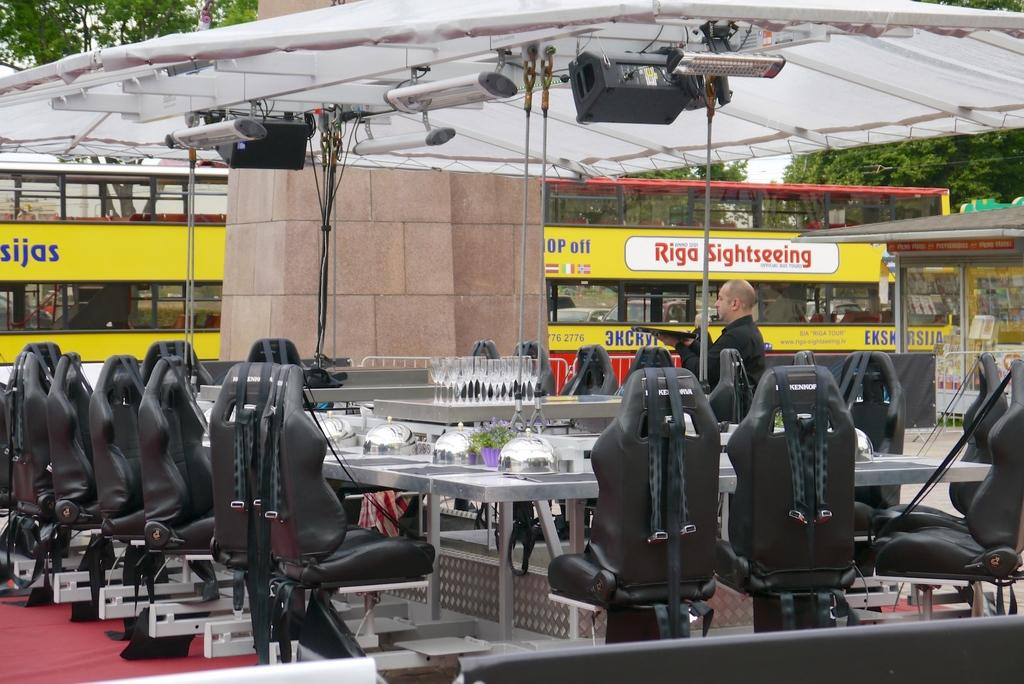Who is present in the image? There is a man in the image. What type of furniture can be seen in the image? There are chairs in the image. What is on the floor in the image? There is a carpet on the floor in the image. What type of tableware is present in the image? There are glasses and dishes in the image. What type of plant is visible in the image? There is a plant in the image. What type of surface is present in the image? There are tables in the image. What type of lighting is present in the image? There are lights in the image. What type of temporary shelter is present in the image? There is a tent in the image. What type of transportation is present in the image? There is a vehicle in the image. What type of natural elements are visible in the image? There are trees in the image. What type of barrier is present in the image? There is a wall in the image. What type of objects are present in the image? There are some objects in the image. Where is the fan located in the image? There is no fan present in the image. What type of hydrant is visible in the image? There is no hydrant present in the image. 